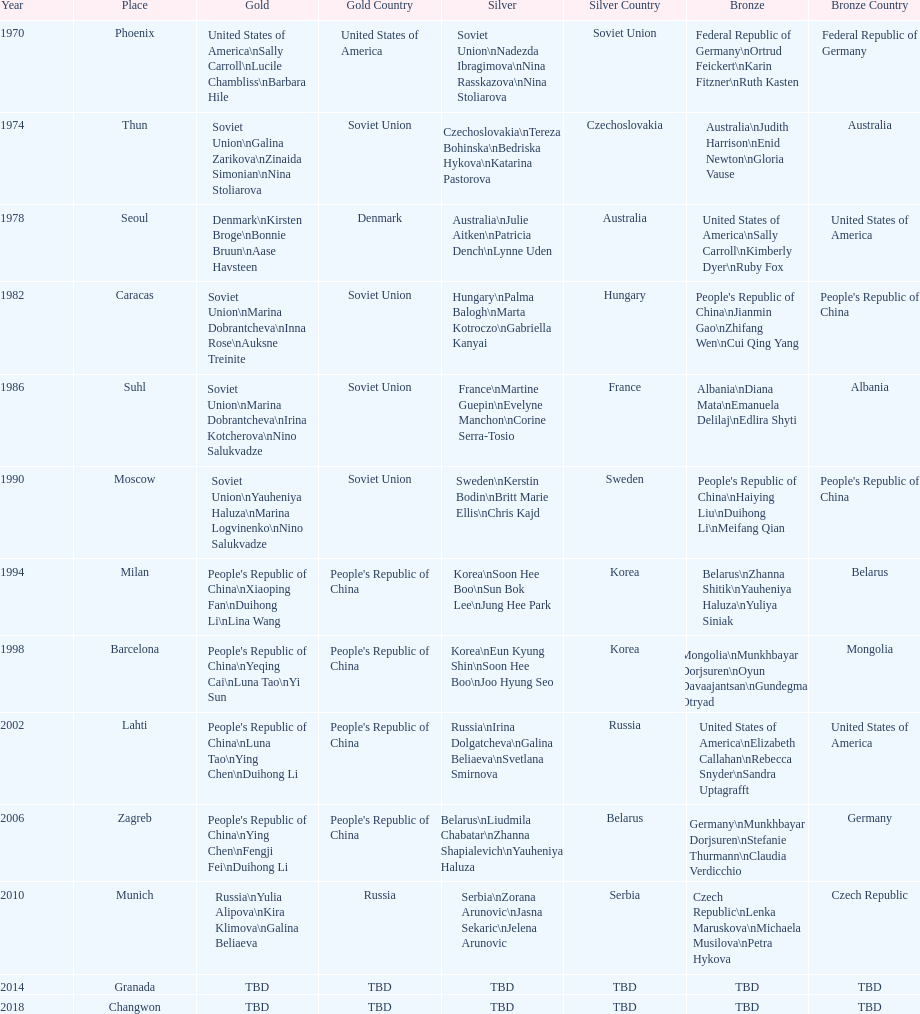What is the first place listed in this chart? Phoenix. 